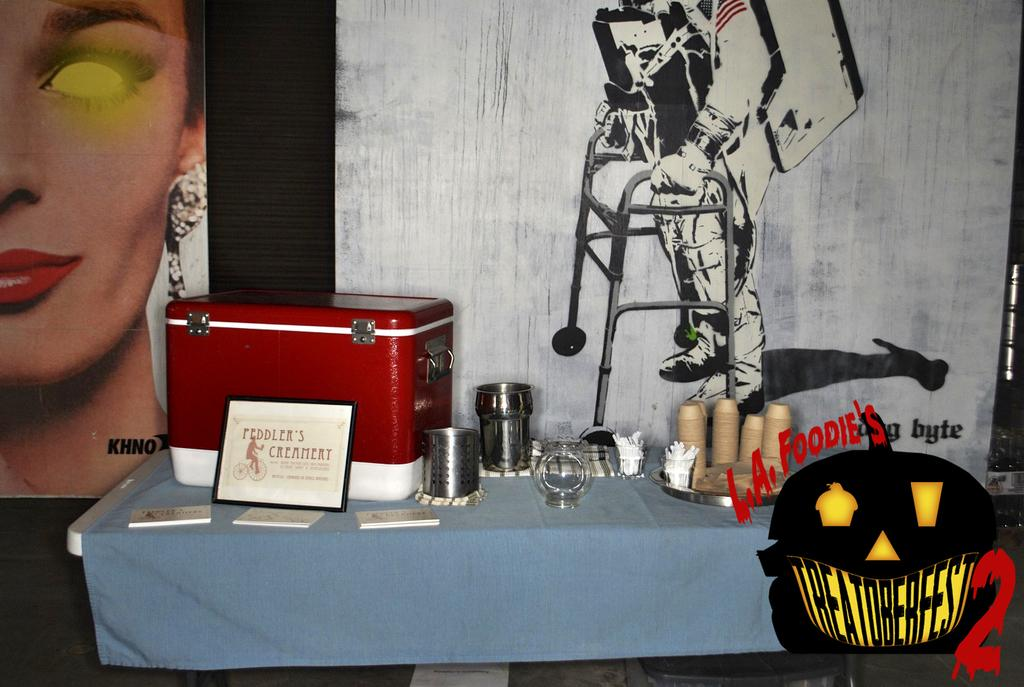<image>
Provide a brief description of the given image. A table covered with a blue table cloth contains dishes, a cooler, and a sign for Peddler's Creamery. 